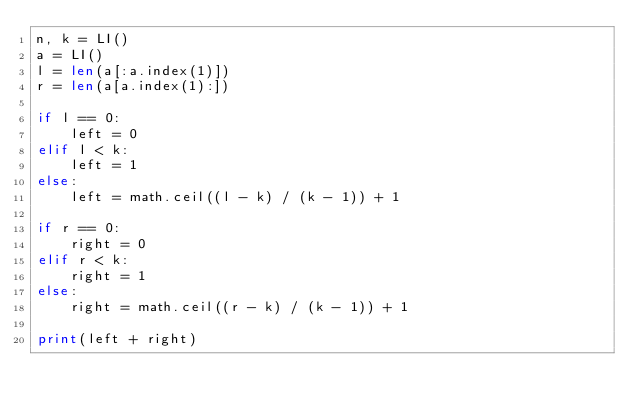Convert code to text. <code><loc_0><loc_0><loc_500><loc_500><_Python_>n, k = LI()
a = LI()
l = len(a[:a.index(1)])
r = len(a[a.index(1):])

if l == 0:
    left = 0
elif l < k:
    left = 1
else:
    left = math.ceil((l - k) / (k - 1)) + 1

if r == 0:
    right = 0
elif r < k:
    right = 1
else:
    right = math.ceil((r - k) / (k - 1)) + 1

print(left + right)</code> 